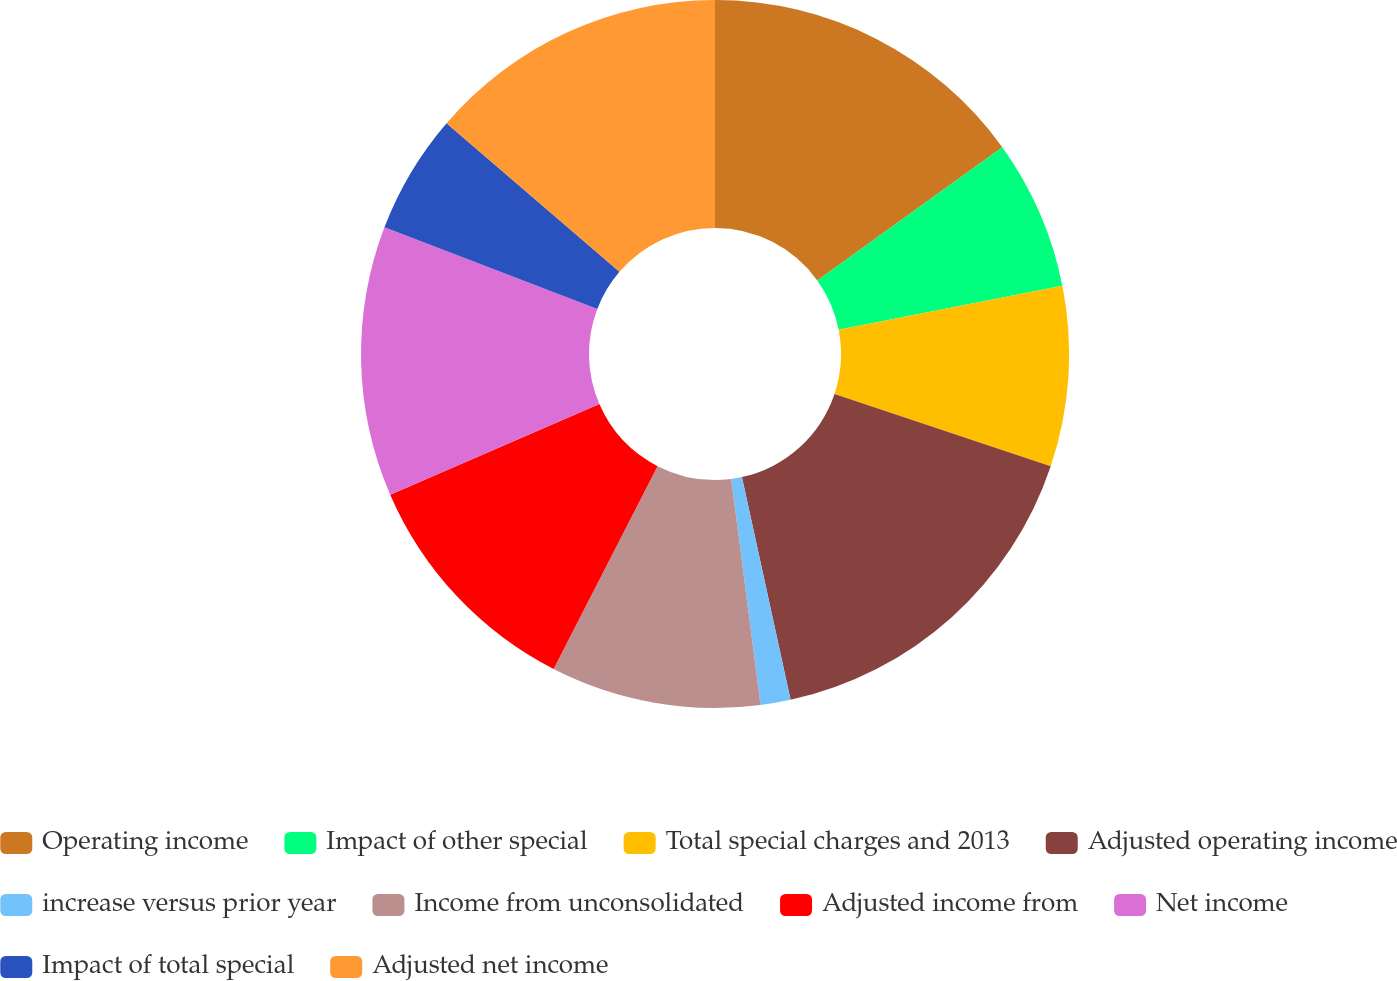Convert chart. <chart><loc_0><loc_0><loc_500><loc_500><pie_chart><fcel>Operating income<fcel>Impact of other special<fcel>Total special charges and 2013<fcel>Adjusted operating income<fcel>increase versus prior year<fcel>Income from unconsolidated<fcel>Adjusted income from<fcel>Net income<fcel>Impact of total special<fcel>Adjusted net income<nl><fcel>15.07%<fcel>6.85%<fcel>8.22%<fcel>16.44%<fcel>1.37%<fcel>9.59%<fcel>10.96%<fcel>12.33%<fcel>5.48%<fcel>13.7%<nl></chart> 